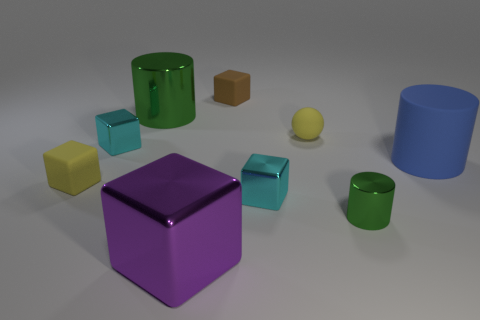What is the size of the shiny thing that is the same color as the tiny cylinder?
Your answer should be very brief. Large. The metallic thing that is the same color as the small metal cylinder is what shape?
Make the answer very short. Cylinder. What number of cubes are tiny cyan metal things or purple shiny objects?
Offer a very short reply. 3. What is the color of the metal cylinder that is the same size as the yellow sphere?
Your response must be concise. Green. How many large objects are on the right side of the tiny green shiny cylinder and behind the blue cylinder?
Provide a short and direct response. 0. What is the material of the blue thing?
Offer a very short reply. Rubber. What number of things are large green balls or big cylinders?
Give a very brief answer. 2. There is a yellow thing in front of the rubber sphere; is it the same size as the cyan cube right of the big green cylinder?
Keep it short and to the point. Yes. What number of other things are the same size as the matte sphere?
Offer a terse response. 5. How many things are either green metal cylinders left of the small green metal object or metallic blocks that are on the right side of the large shiny cylinder?
Your answer should be compact. 3. 